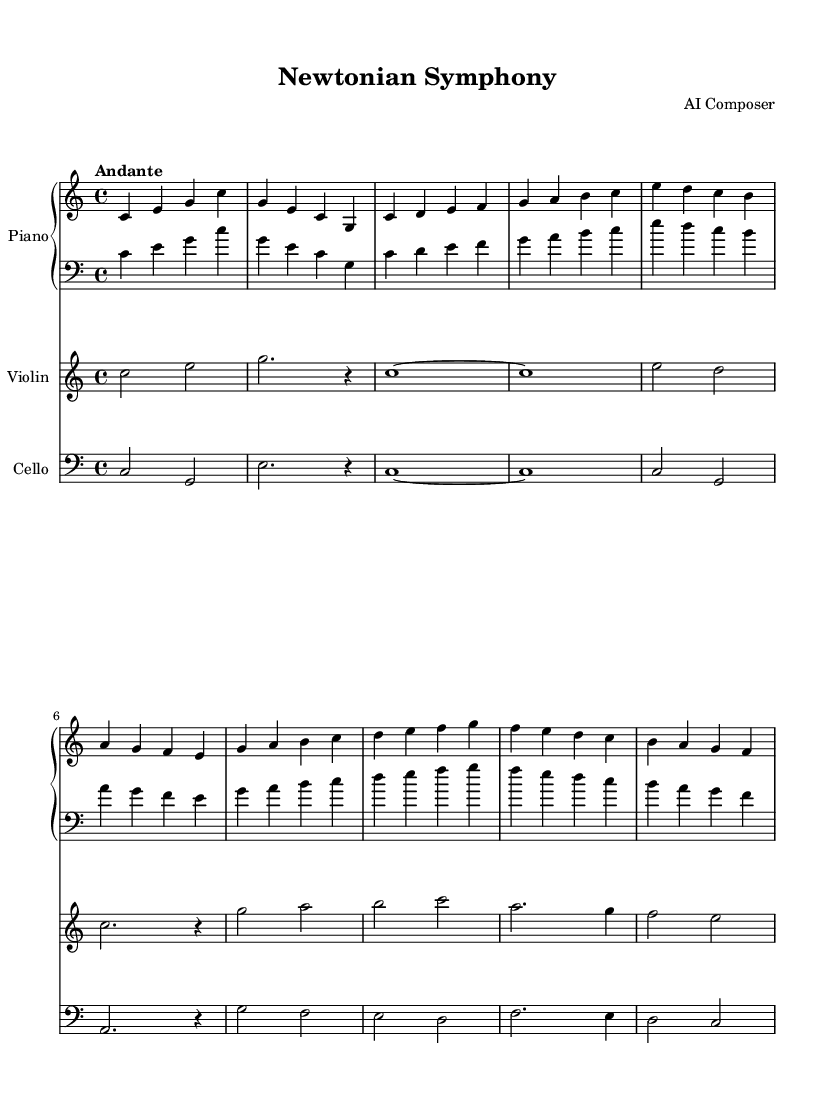What is the key signature of this music? The key signature, indicated at the beginning of the piece, shows no sharps or flats. This indicates that the piece is in C major.
Answer: C major What is the time signature of this piece? The time signature is located just after the key signature at the beginning. It shows 4 beats per measure, thus it is notated as 4/4.
Answer: 4/4 What is the tempo marking for this composition? The tempo marking is provided at the start of the score, which indicates the intended speed of the piece. It is labeled "Andante," suggesting a moderate pace.
Answer: Andante How many measures are in Theme A? Theme A is identified in the score and comprises 4 measures of music. By counting from the start of Theme A to its end, we find there are exactly 4.
Answer: 4 Which instruments are included in this score? The score displays three distinct parts labeled accordingly. They are Piano, Violin, and Cello, each indicated in the header of their respective staves.
Answer: Piano, Violin, Cello What melodic figure is introduced in the introduction? By examining the initial measures, the introduction prominently features the notes C, E, and G, characterizing the opening melodic motif in the score.
Answer: C, E, G 